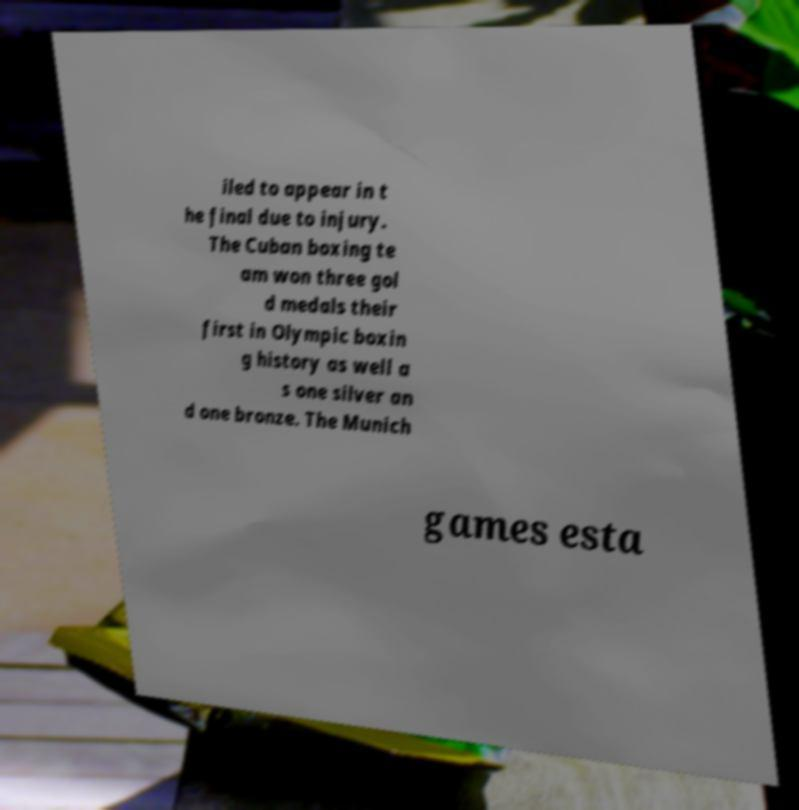I need the written content from this picture converted into text. Can you do that? iled to appear in t he final due to injury. The Cuban boxing te am won three gol d medals their first in Olympic boxin g history as well a s one silver an d one bronze. The Munich games esta 